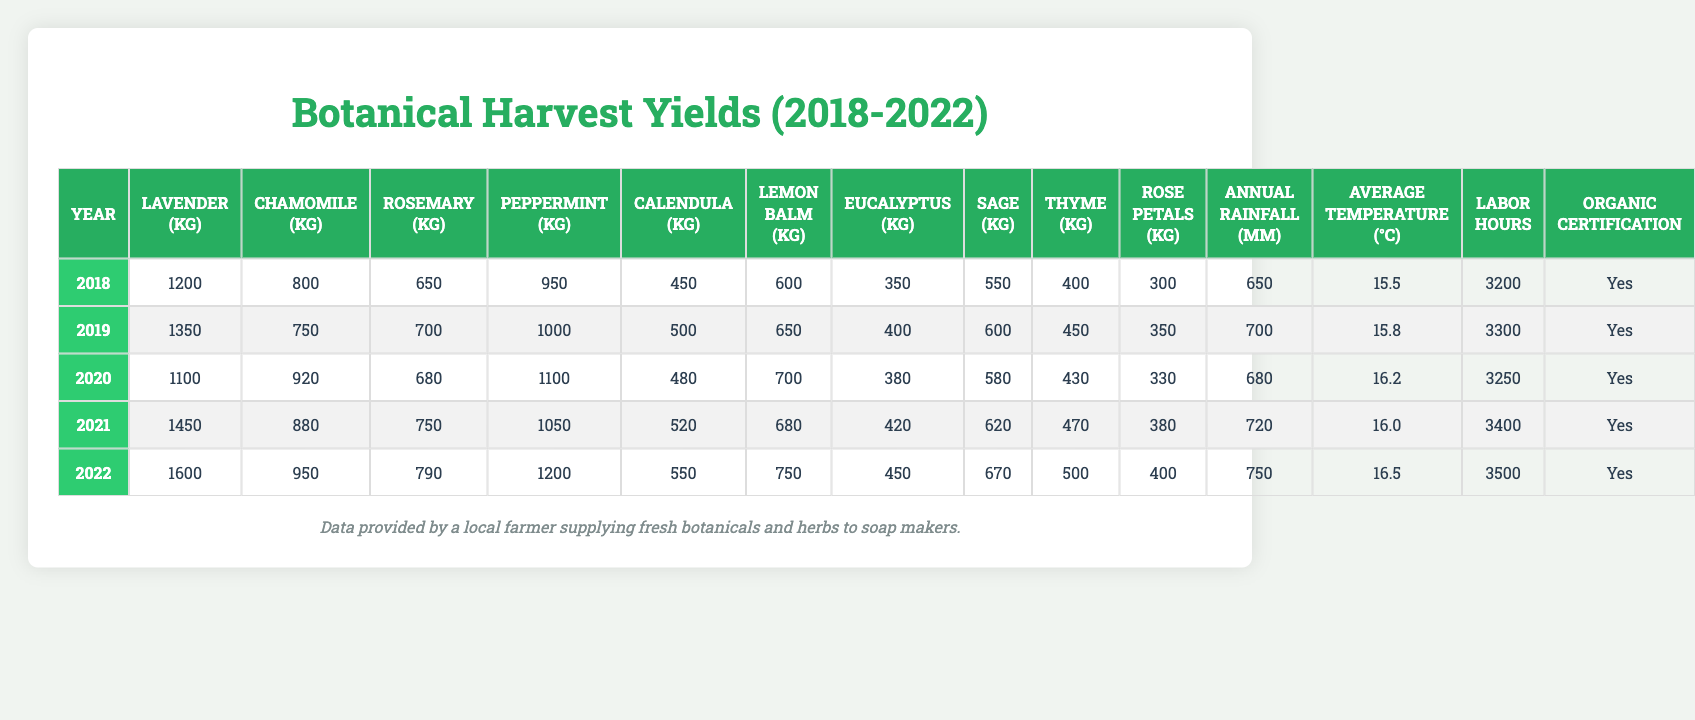What was the yield of Lavender in 2021? The table directly shows that the yield of Lavender in 2021 is listed under the "Lavender (kg)" column for the year 2021. It is 1450 kg.
Answer: 1450 kg What is the average yield of Chamomile over the five years? To find the average yield of Chamomile, sum the yields from 2018 to 2022: (800 + 750 + 920 + 880 + 950) = 4300 kg. Then divide by the number of years: 4300 / 5 = 860 kg.
Answer: 860 kg Did the yield of Eucalyptus increase every year? By checking the yields from 2018 to 2022, the yields of Eucalyptus are 350, 400, 380, 420, and 450 kg. We see that it increased from 2018 to 2019, decreased in 2020, and then increased again in 2021 and 2022. So, it did not increase every year.
Answer: No In which year was the highest yield of Peppermint recorded? The yields of Peppermint by year are 950, 1000, 1100, 1050, and 1200 kg. The highest yield is in 2022 when it reached 1200 kg.
Answer: 2022 What is the total yield of Sage across all years? To calculate the total yield of Sage, we sum the yields: (550 + 600 + 580 + 620 + 670) = 3020 kg.
Answer: 3020 kg How much did the yield of Rosemary increase from 2018 to 2022? The yield of Rosemary in 2018 was 650 kg and in 2022 it was 790 kg. The increase is calculated as: 790 - 650 = 140 kg.
Answer: 140 kg What percentage of the total yield in 2020 came from Lavender? The total yield in 2020 can be calculated by summing all the yields for that year: (1100 + 920 + 680 + 1100 + 480 + 700 + 380 + 580+ 430 + 330) = 6700 kg. The yield of Lavender in that year is 1100 kg. The percentage is (1100 / 6700) * 100 = 16.42%.
Answer: 16.42% Was there any year where the annual rainfall was less than 700 mm? Reviewing the annual rainfall data: 650, 700, 680, 720, 750 mm, we see that in 2018, the rainfall was less than 700 mm (650 mm).
Answer: Yes What is the average temperature over the five years? Adding the average temperatures for each year: (15.5 + 15.8 + 16.2 + 16.0 + 16.5) = 80. This total divided by 5 gives an average temperature of 80 / 5 = 16 °C.
Answer: 16 °C In what year did the labor hours exceed 3400 hours for the first time? The labor hours data is: 3200, 3300, 3250, 3400, and 3500 hours. The first year exceeding 3400 hours is 2022 with 3500 hours.
Answer: 2022 